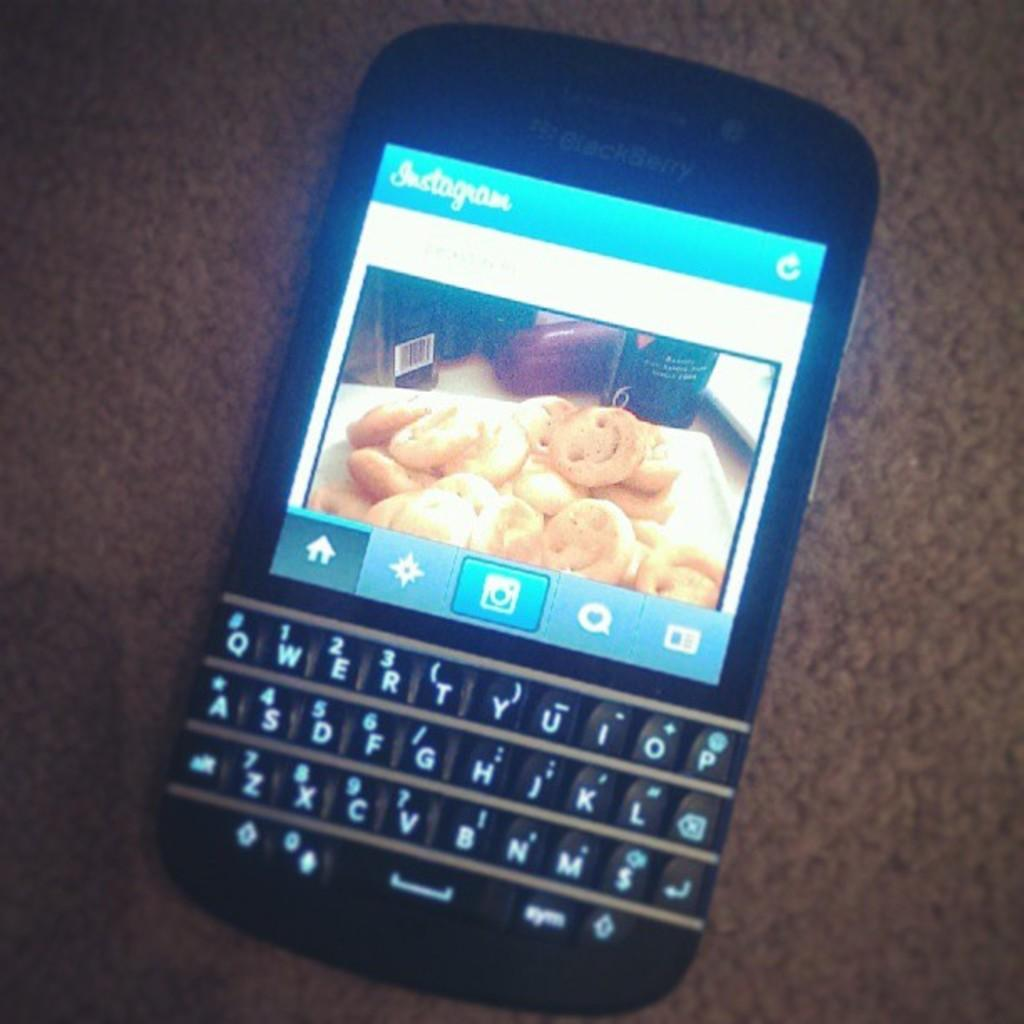<image>
Describe the image concisely. Blackberry phone shows a picture of cookies on instagram 